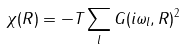<formula> <loc_0><loc_0><loc_500><loc_500>\chi ( { R } ) = - T \sum _ { l } G ( i \omega _ { l } , { R } ) ^ { 2 }</formula> 